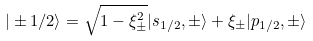Convert formula to latex. <formula><loc_0><loc_0><loc_500><loc_500>| \pm 1 / 2 \rangle = \sqrt { 1 - \xi ^ { 2 } _ { \pm } } | s _ { 1 / 2 } , \pm \rangle + \xi _ { \pm } | p _ { 1 / 2 } , \pm \rangle</formula> 